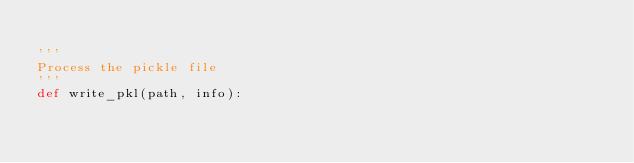<code> <loc_0><loc_0><loc_500><loc_500><_Python_>
'''
Process the pickle file
'''
def write_pkl(path, info):</code> 